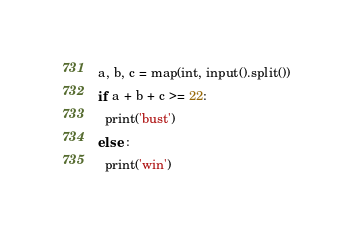Convert code to text. <code><loc_0><loc_0><loc_500><loc_500><_Python_>a, b, c = map(int, input().split())
if a + b + c >= 22:
  print('bust')
else :
  print('win')</code> 